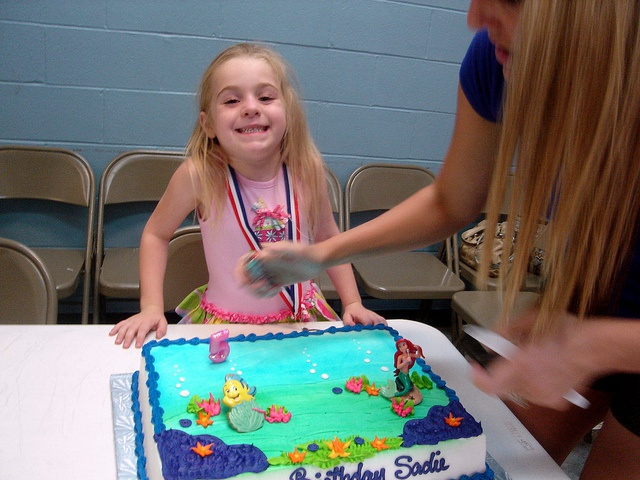Describe the objects in this image and their specific colors. I can see people in teal, maroon, black, and brown tones, dining table in teal, lavender, turquoise, darkgray, and aquamarine tones, cake in teal, turquoise, aquamarine, navy, and blue tones, people in teal, brown, lightpink, and tan tones, and chair in teal, gray, black, and purple tones in this image. 